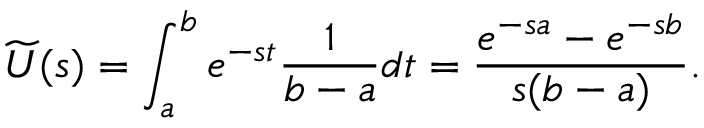Convert formula to latex. <formula><loc_0><loc_0><loc_500><loc_500>{ \widetilde { U } } ( s ) = \int _ { a } ^ { b } e ^ { - s t } { \frac { 1 } { b - a } } d t = { \frac { e ^ { - s a } - e ^ { - s b } } { s ( b - a ) } } .</formula> 